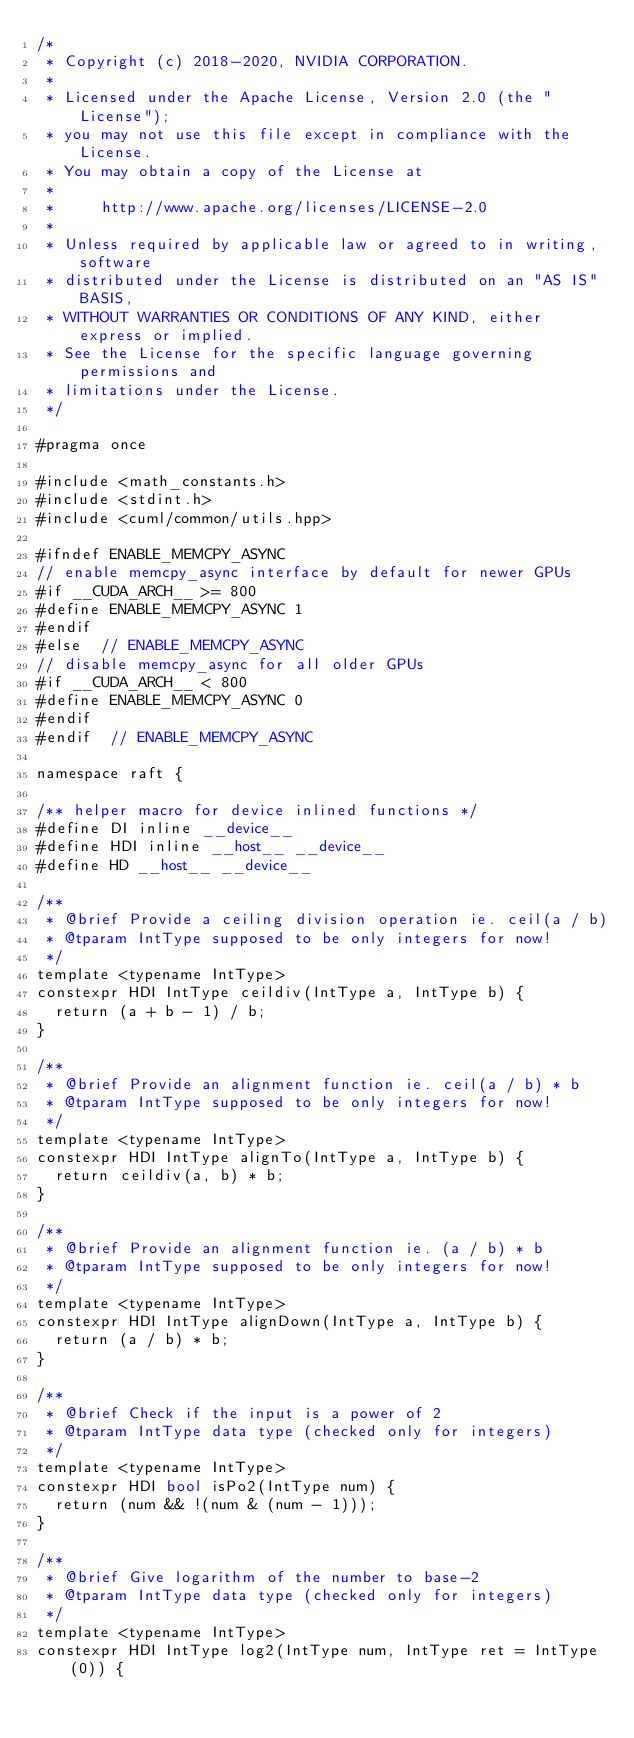Convert code to text. <code><loc_0><loc_0><loc_500><loc_500><_Cuda_>/*
 * Copyright (c) 2018-2020, NVIDIA CORPORATION.
 *
 * Licensed under the Apache License, Version 2.0 (the "License");
 * you may not use this file except in compliance with the License.
 * You may obtain a copy of the License at
 *
 *     http://www.apache.org/licenses/LICENSE-2.0
 *
 * Unless required by applicable law or agreed to in writing, software
 * distributed under the License is distributed on an "AS IS" BASIS,
 * WITHOUT WARRANTIES OR CONDITIONS OF ANY KIND, either express or implied.
 * See the License for the specific language governing permissions and
 * limitations under the License.
 */

#pragma once

#include <math_constants.h>
#include <stdint.h>
#include <cuml/common/utils.hpp>

#ifndef ENABLE_MEMCPY_ASYNC
// enable memcpy_async interface by default for newer GPUs
#if __CUDA_ARCH__ >= 800
#define ENABLE_MEMCPY_ASYNC 1
#endif
#else  // ENABLE_MEMCPY_ASYNC
// disable memcpy_async for all older GPUs
#if __CUDA_ARCH__ < 800
#define ENABLE_MEMCPY_ASYNC 0
#endif
#endif  // ENABLE_MEMCPY_ASYNC

namespace raft {

/** helper macro for device inlined functions */
#define DI inline __device__
#define HDI inline __host__ __device__
#define HD __host__ __device__

/**
 * @brief Provide a ceiling division operation ie. ceil(a / b)
 * @tparam IntType supposed to be only integers for now!
 */
template <typename IntType>
constexpr HDI IntType ceildiv(IntType a, IntType b) {
  return (a + b - 1) / b;
}

/**
 * @brief Provide an alignment function ie. ceil(a / b) * b
 * @tparam IntType supposed to be only integers for now!
 */
template <typename IntType>
constexpr HDI IntType alignTo(IntType a, IntType b) {
  return ceildiv(a, b) * b;
}

/**
 * @brief Provide an alignment function ie. (a / b) * b
 * @tparam IntType supposed to be only integers for now!
 */
template <typename IntType>
constexpr HDI IntType alignDown(IntType a, IntType b) {
  return (a / b) * b;
}

/**
 * @brief Check if the input is a power of 2
 * @tparam IntType data type (checked only for integers)
 */
template <typename IntType>
constexpr HDI bool isPo2(IntType num) {
  return (num && !(num & (num - 1)));
}

/**
 * @brief Give logarithm of the number to base-2
 * @tparam IntType data type (checked only for integers)
 */
template <typename IntType>
constexpr HDI IntType log2(IntType num, IntType ret = IntType(0)) {</code> 